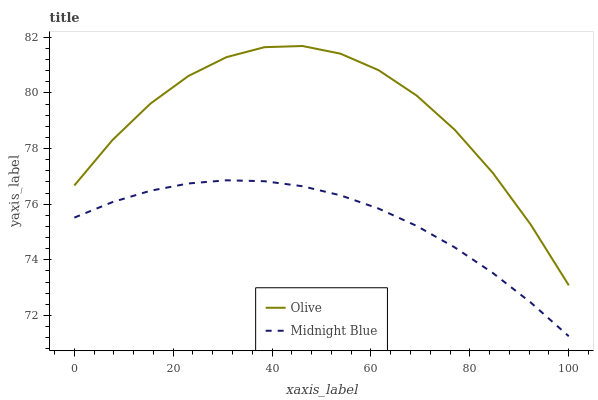Does Midnight Blue have the minimum area under the curve?
Answer yes or no. Yes. Does Olive have the maximum area under the curve?
Answer yes or no. Yes. Does Midnight Blue have the maximum area under the curve?
Answer yes or no. No. Is Midnight Blue the smoothest?
Answer yes or no. Yes. Is Olive the roughest?
Answer yes or no. Yes. Is Midnight Blue the roughest?
Answer yes or no. No. Does Olive have the highest value?
Answer yes or no. Yes. Does Midnight Blue have the highest value?
Answer yes or no. No. Is Midnight Blue less than Olive?
Answer yes or no. Yes. Is Olive greater than Midnight Blue?
Answer yes or no. Yes. Does Midnight Blue intersect Olive?
Answer yes or no. No. 